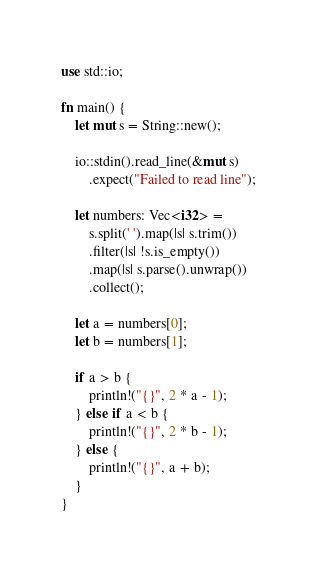<code> <loc_0><loc_0><loc_500><loc_500><_Rust_>use std::io;

fn main() {
    let mut s = String::new();

    io::stdin().read_line(&mut s)
        .expect("Failed to read line");

    let numbers: Vec<i32> =
        s.split(' ').map(|s| s.trim())
        .filter(|s| !s.is_empty())
        .map(|s| s.parse().unwrap())
        .collect();

    let a = numbers[0];
    let b = numbers[1];

    if a > b {
        println!("{}", 2 * a - 1);
    } else if a < b {
        println!("{}", 2 * b - 1);
    } else {
        println!("{}", a + b);
    }
}
</code> 